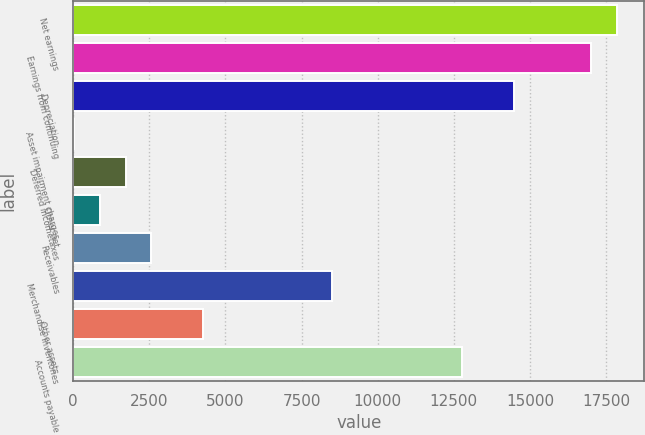Convert chart. <chart><loc_0><loc_0><loc_500><loc_500><bar_chart><fcel>Net earnings<fcel>Earnings from continuing<fcel>Depreciation<fcel>Asset impairment charges<fcel>Deferred incometaxes<fcel>Other net<fcel>Receivables<fcel>Merchandise inventories<fcel>Other assets<fcel>Accounts payable<nl><fcel>17861.5<fcel>17012<fcel>14463.5<fcel>22<fcel>1721<fcel>871.5<fcel>2570.5<fcel>8517<fcel>4269.5<fcel>12764.5<nl></chart> 